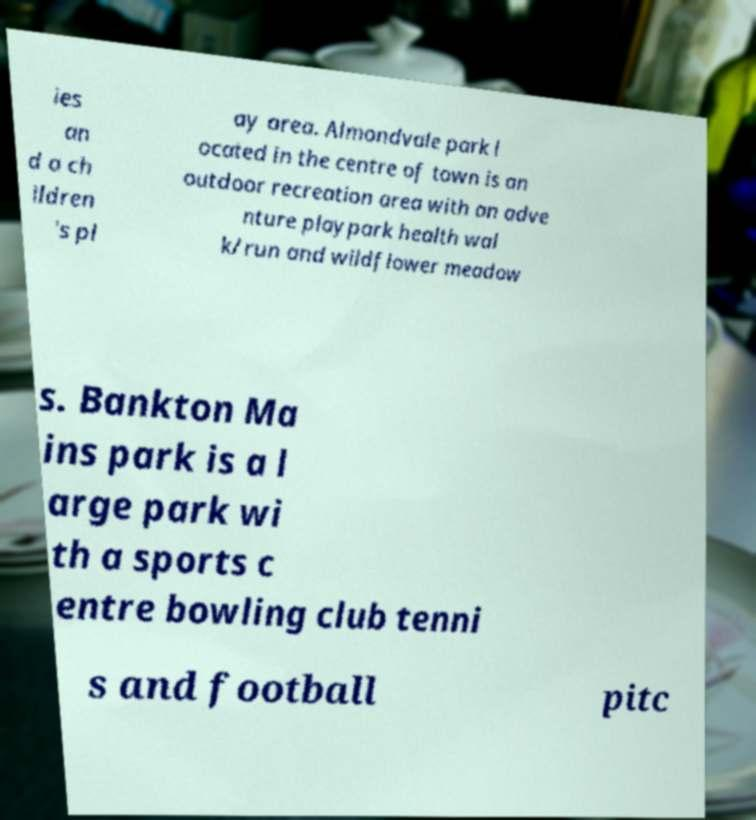Can you read and provide the text displayed in the image?This photo seems to have some interesting text. Can you extract and type it out for me? ies an d a ch ildren 's pl ay area. Almondvale park l ocated in the centre of town is an outdoor recreation area with an adve nture playpark health wal k/run and wildflower meadow s. Bankton Ma ins park is a l arge park wi th a sports c entre bowling club tenni s and football pitc 